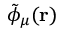Convert formula to latex. <formula><loc_0><loc_0><loc_500><loc_500>\tilde { \phi } _ { \mu } ( r )</formula> 